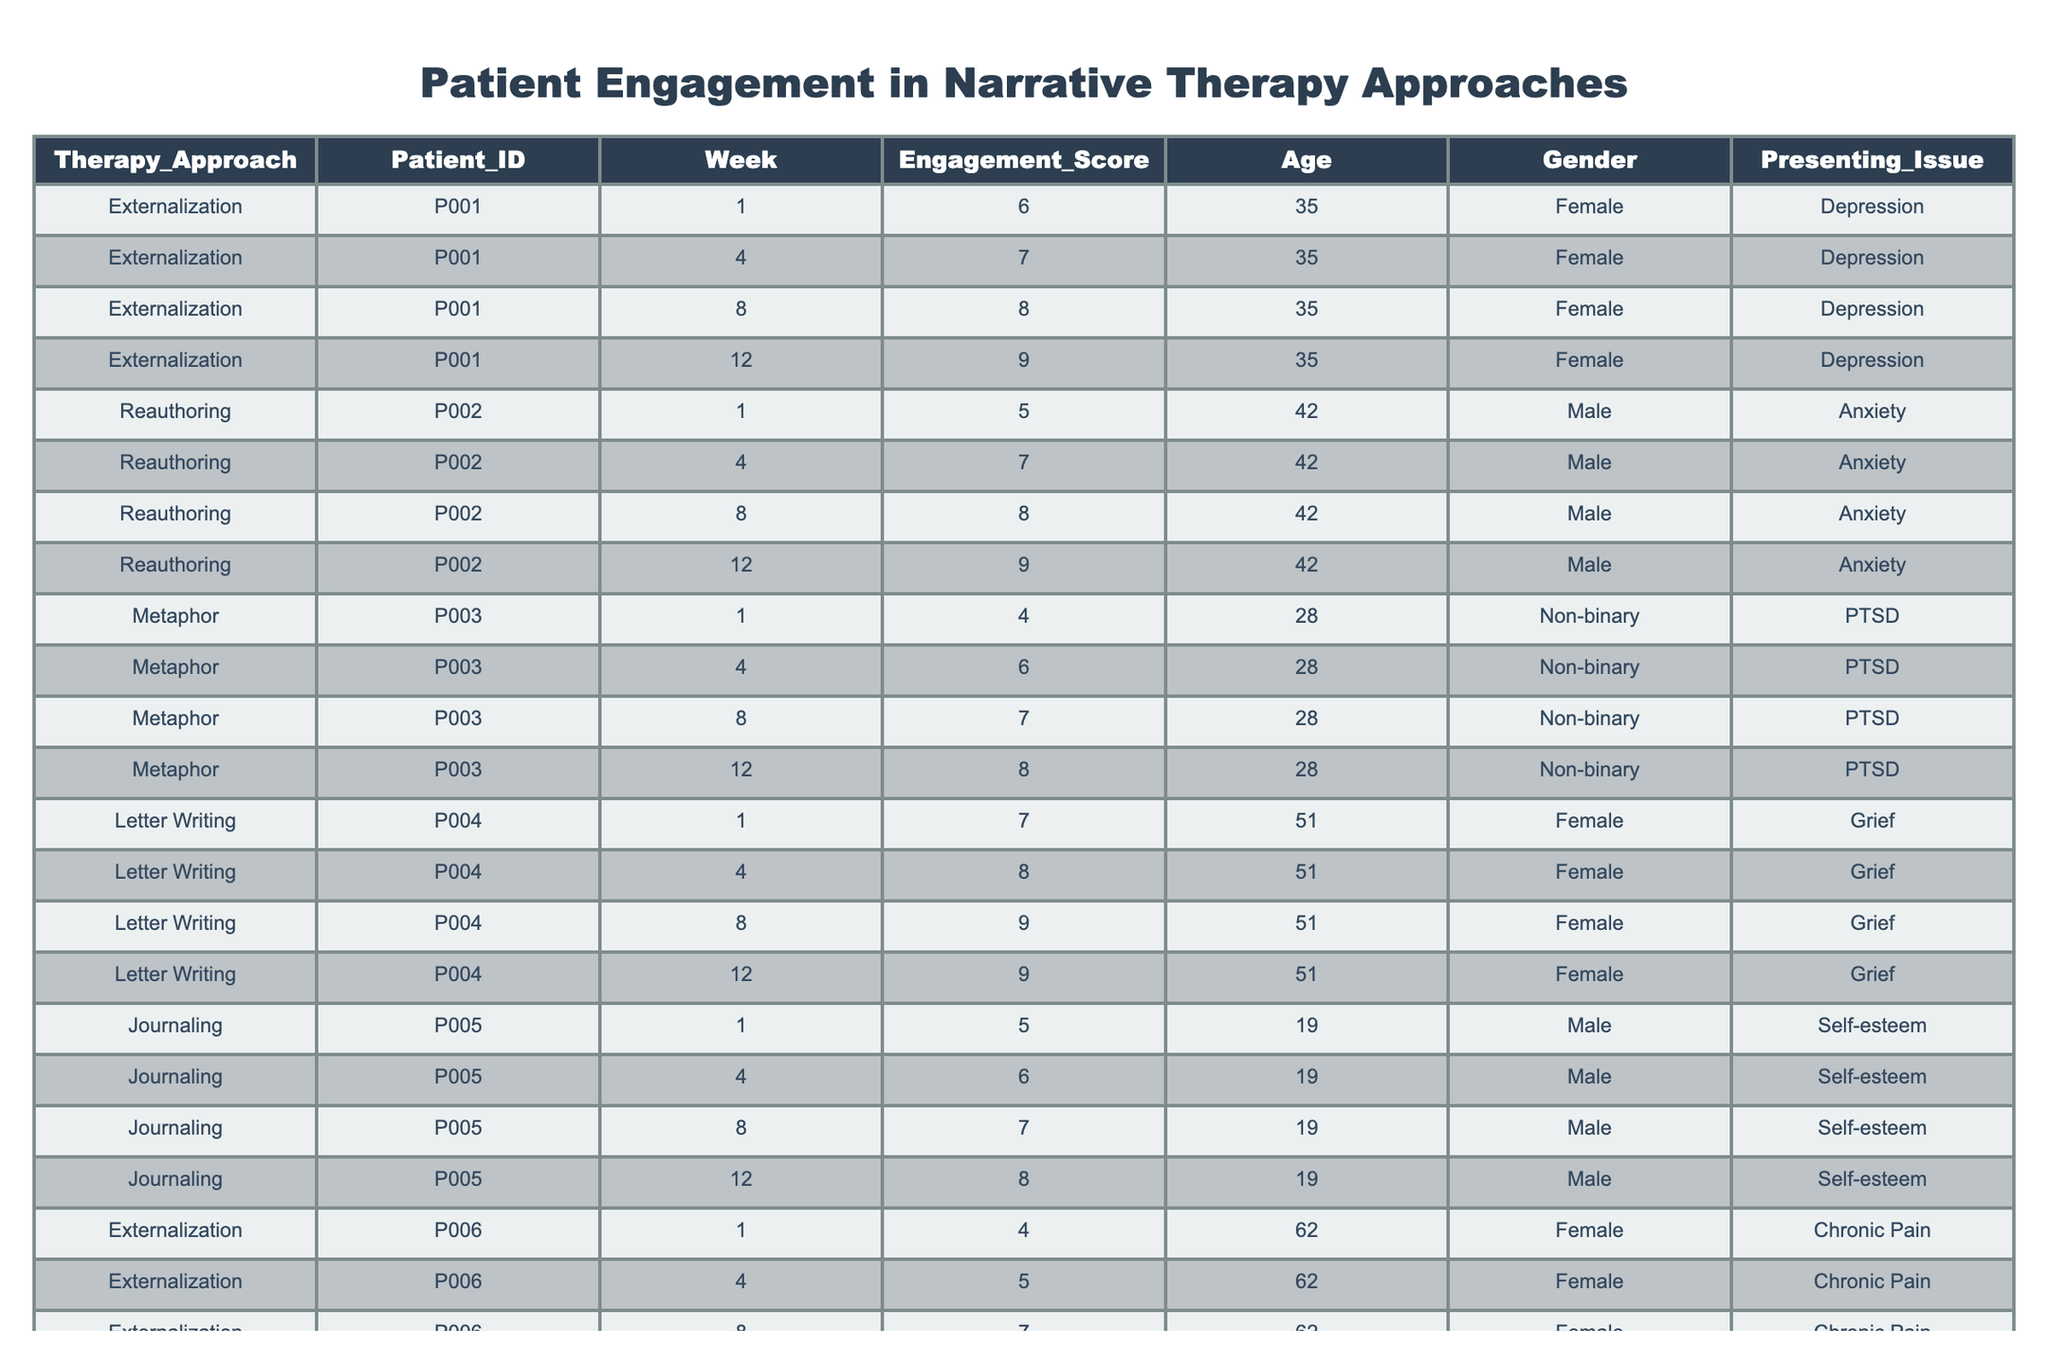What was the highest engagement score recorded for the Externalization therapy approach? Looking at the table, the highest engagement score for Externalization occurred in Week 12 with a score of 9 for Patient ID P001 and P006. Both patients achieved this highest score.
Answer: 9 What is the average engagement score for the Reauthoring approach? The engagement scores for Reauthoring are 6, 7, 8, and 9 (from Patients P002 and P007). Summing these scores yields 6 + 7 + 8 + 9 = 30. There are 4 scores, so the average is 30 / 4 = 7.5.
Answer: 7.5 Did any patient achieve a score of 10 during the therapy? By reviewing the scores in the table, none of the recorded engagement scores exceeded 9, indicating that no patient reached a score of 10.
Answer: No Which narrative therapy approach had the highest average engagement score across all weeks? First, calculate the average scores for each approach: Externalization averages to (6 + 7 + 8 + 9) / 4 = 7.5, Reauthoring averages to (5 + 7 + 8 + 9) / 4 = 7.25, Metaphor averages to (4 + 6 + 7 + 8) / 4 = 6.25, Letter Writing averages to (7 + 8 + 9 + 9) / 4 = 8.25, and Journaling averages to (5 + 6 + 7 + 8) / 4 = 6.5. The highest average score is from Letter Writing: 8.25.
Answer: Letter Writing How many patients engaged with the Journaling approach? The table lists data for only one patient (P005) participating in the Journaling approach, indicated by the presence of engagement scores throughout the weeks.
Answer: 1 What is the total number of engagement scores recorded for the Metaphor approach? By counting the entries for the Metaphor approach in the table, there are a total of 4 engagement scores recorded (1 score for each of the 4 weeks).
Answer: 4 Which presenting issue had the most representation among patients in the table? The issues listed are Depression (2), Anxiety (2), PTSD (1), Grief (1), Self-esteem (1), and Relationship Issues (1). Depression and Anxiety are the most represented, with 2 patients each.
Answer: Depression and Anxiety Was there any change in engagement score for Patient P004 from Week 1 to Week 12? For Patient P004, the engagement score in Week 1 was 7 and in Week 12 was 9, indicating an increase over the treatment period.
Answer: Yes, there was an increase 